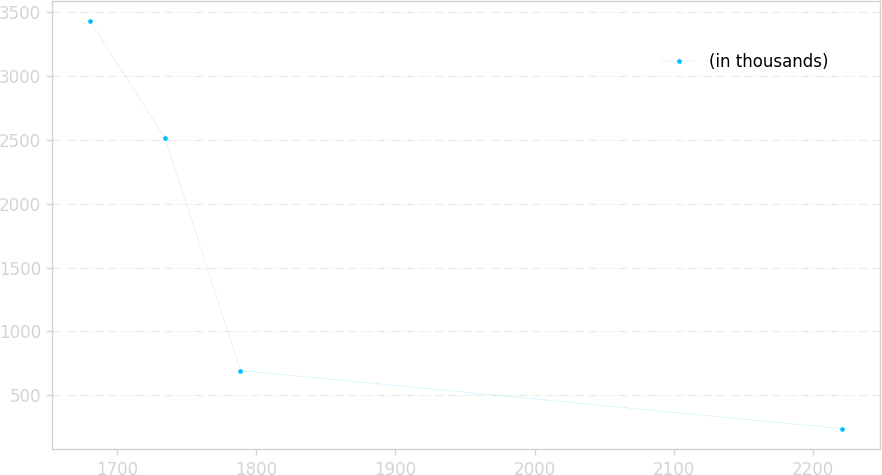<chart> <loc_0><loc_0><loc_500><loc_500><line_chart><ecel><fcel>(in thousands)<nl><fcel>1680.68<fcel>3430.15<nl><fcel>1734.7<fcel>2512.92<nl><fcel>1788.72<fcel>693.54<nl><fcel>2220.86<fcel>237.6<nl></chart> 